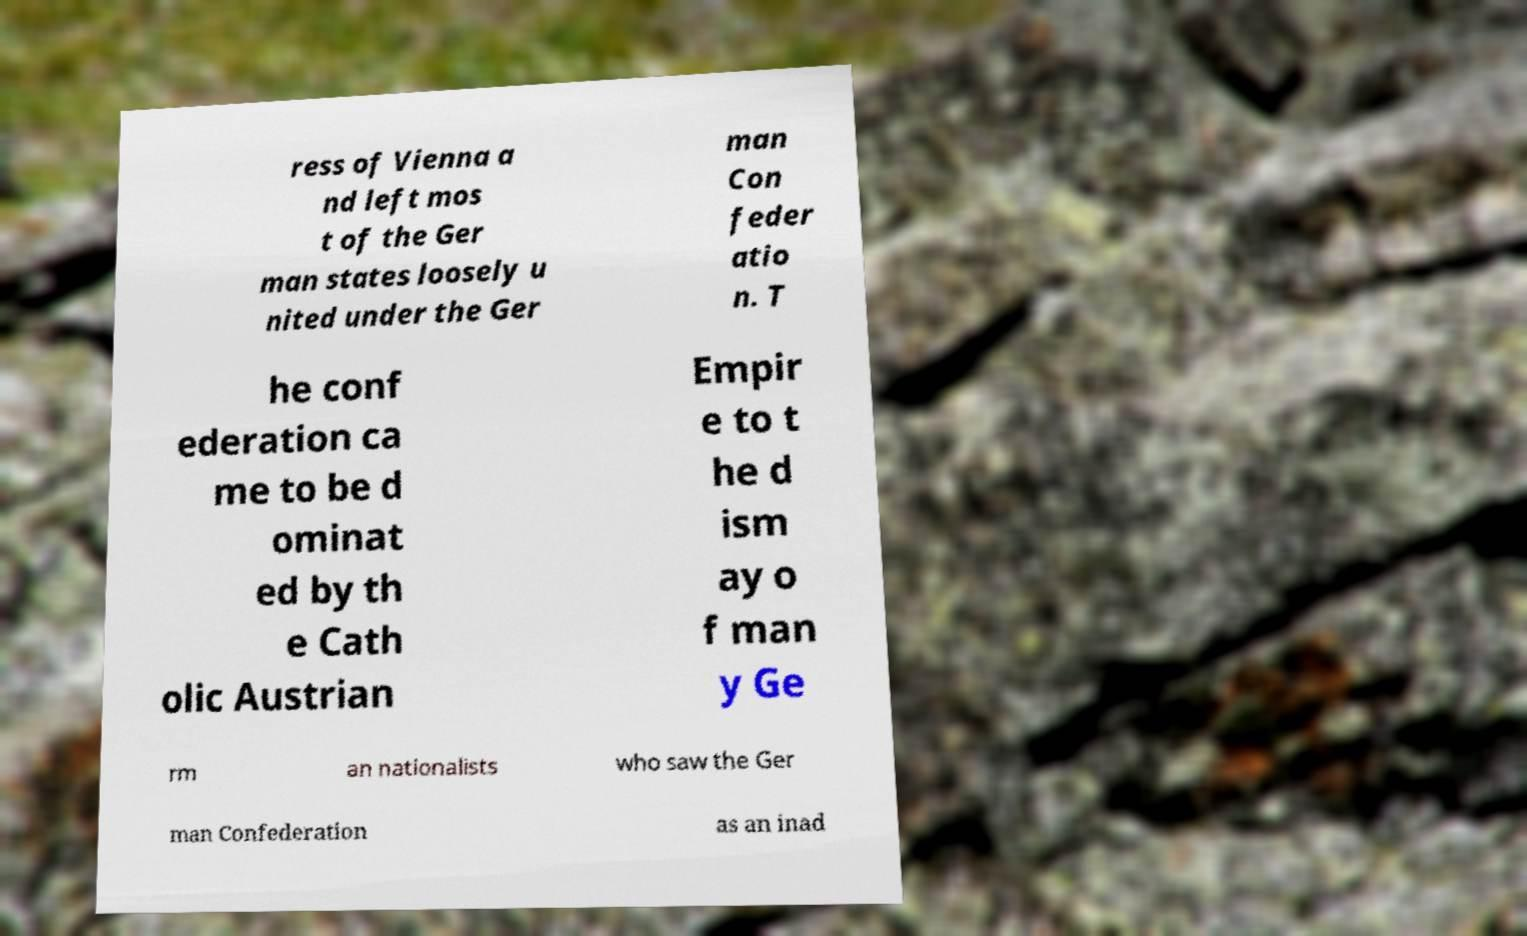For documentation purposes, I need the text within this image transcribed. Could you provide that? ress of Vienna a nd left mos t of the Ger man states loosely u nited under the Ger man Con feder atio n. T he conf ederation ca me to be d ominat ed by th e Cath olic Austrian Empir e to t he d ism ay o f man y Ge rm an nationalists who saw the Ger man Confederation as an inad 